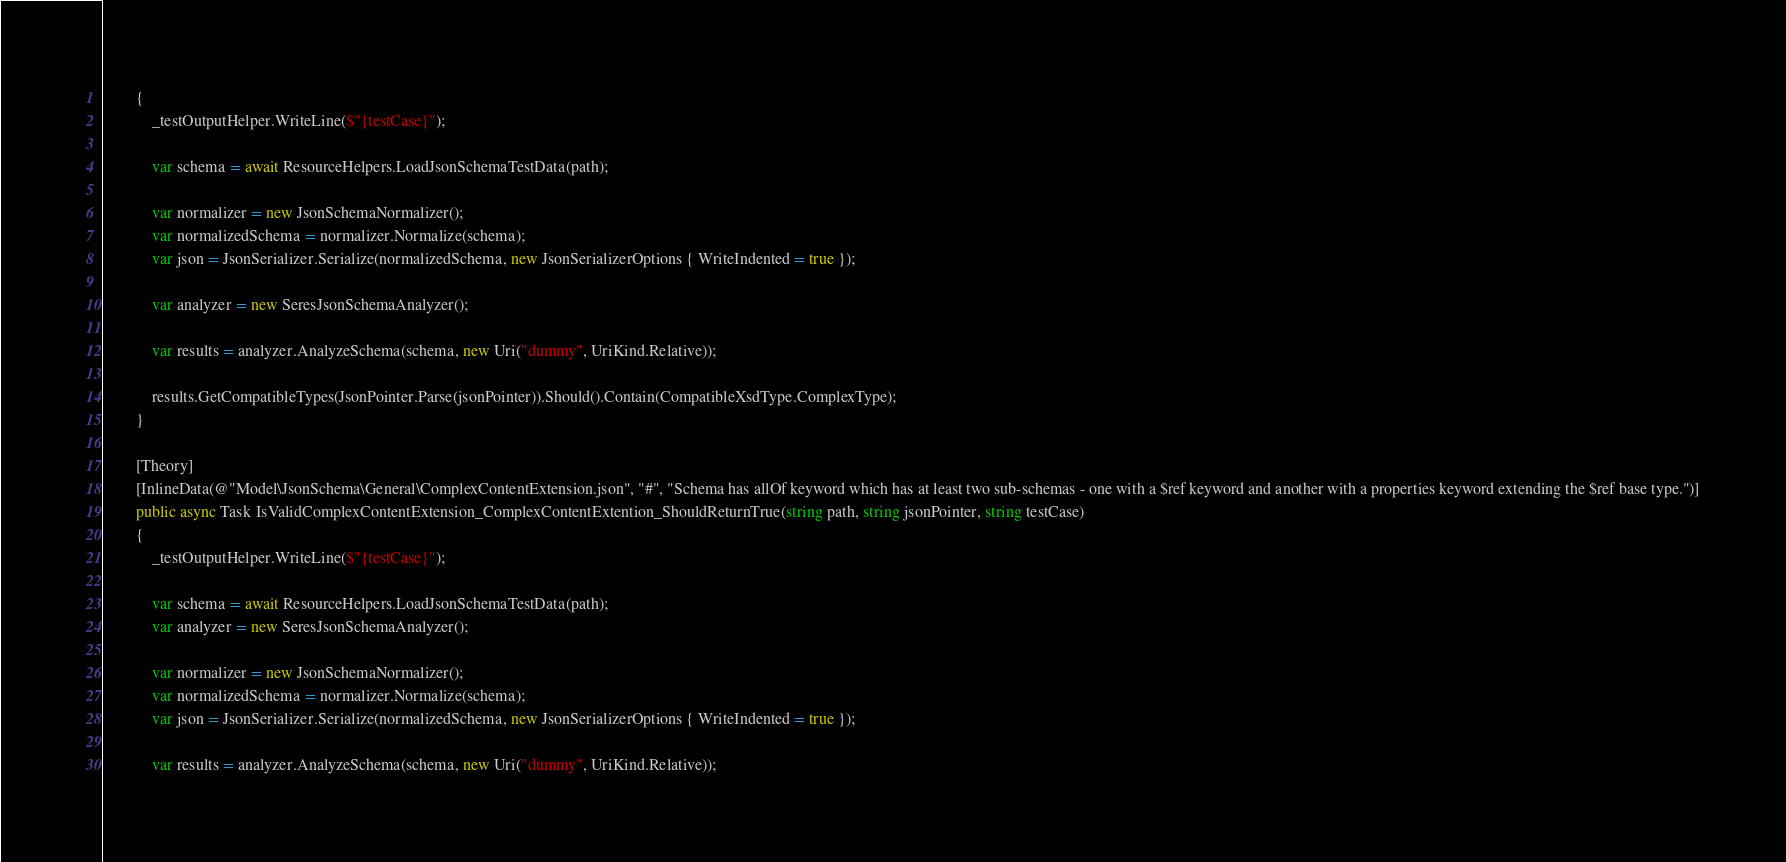<code> <loc_0><loc_0><loc_500><loc_500><_C#_>        {
            _testOutputHelper.WriteLine($"{testCase}");

            var schema = await ResourceHelpers.LoadJsonSchemaTestData(path);

            var normalizer = new JsonSchemaNormalizer();
            var normalizedSchema = normalizer.Normalize(schema);
            var json = JsonSerializer.Serialize(normalizedSchema, new JsonSerializerOptions { WriteIndented = true });

            var analyzer = new SeresJsonSchemaAnalyzer();

            var results = analyzer.AnalyzeSchema(schema, new Uri("dummy", UriKind.Relative));

            results.GetCompatibleTypes(JsonPointer.Parse(jsonPointer)).Should().Contain(CompatibleXsdType.ComplexType);
        }

        [Theory]
        [InlineData(@"Model\JsonSchema\General\ComplexContentExtension.json", "#", "Schema has allOf keyword which has at least two sub-schemas - one with a $ref keyword and another with a properties keyword extending the $ref base type.")]
        public async Task IsValidComplexContentExtension_ComplexContentExtention_ShouldReturnTrue(string path, string jsonPointer, string testCase)
        {
            _testOutputHelper.WriteLine($"{testCase}");

            var schema = await ResourceHelpers.LoadJsonSchemaTestData(path);
            var analyzer = new SeresJsonSchemaAnalyzer();

            var normalizer = new JsonSchemaNormalizer();
            var normalizedSchema = normalizer.Normalize(schema);
            var json = JsonSerializer.Serialize(normalizedSchema, new JsonSerializerOptions { WriteIndented = true });

            var results = analyzer.AnalyzeSchema(schema, new Uri("dummy", UriKind.Relative));
</code> 